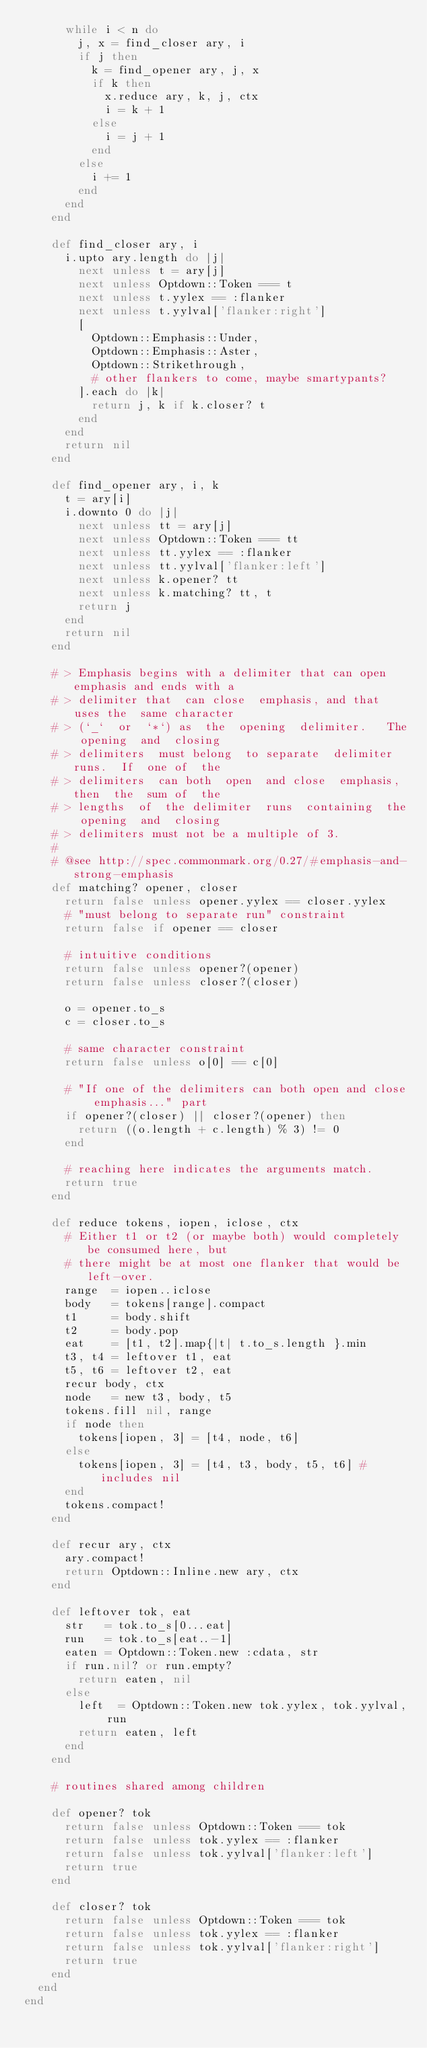Convert code to text. <code><loc_0><loc_0><loc_500><loc_500><_Ruby_>      while i < n do
        j, x = find_closer ary, i
        if j then
          k = find_opener ary, j, x
          if k then
            x.reduce ary, k, j, ctx
            i = k + 1
          else
            i = j + 1
          end
        else
          i += 1
        end
      end
    end

    def find_closer ary, i
      i.upto ary.length do |j|
        next unless t = ary[j]
        next unless Optdown::Token === t
        next unless t.yylex == :flanker
        next unless t.yylval['flanker:right']
        [
          Optdown::Emphasis::Under,
          Optdown::Emphasis::Aster,
          Optdown::Strikethrough,
          # other flankers to come, maybe smartypants?
        ].each do |k|
          return j, k if k.closer? t
        end
      end
      return nil
    end

    def find_opener ary, i, k
      t = ary[i]
      i.downto 0 do |j|
        next unless tt = ary[j]
        next unless Optdown::Token === tt
        next unless tt.yylex == :flanker
        next unless tt.yylval['flanker:left']
        next unless k.opener? tt
        next unless k.matching? tt, t
        return j
      end
      return nil
    end

    # > Emphasis begins with a delimiter that can open emphasis and ends with a
    # > delimiter that  can close  emphasis, and that  uses the  same character
    # > (`_`  or  `*`) as  the  opening  delimiter.   The opening  and  closing
    # > delimiters  must belong  to separate  delimiter  runs.  If  one of  the
    # > delimiters  can both  open  and close  emphasis, then  the  sum of  the
    # > lengths  of  the delimiter  runs  containing  the opening  and  closing
    # > delimiters must not be a multiple of 3.
    #
    # @see http://spec.commonmark.org/0.27/#emphasis-and-strong-emphasis
    def matching? opener, closer
      return false unless opener.yylex == closer.yylex
      # "must belong to separate run" constraint
      return false if opener == closer

      # intuitive conditions
      return false unless opener?(opener)
      return false unless closer?(closer)

      o = opener.to_s
      c = closer.to_s

      # same character constraint
      return false unless o[0] == c[0]

      # "If one of the delimiters can both open and close emphasis..." part
      if opener?(closer) || closer?(opener) then
        return ((o.length + c.length) % 3) != 0
      end

      # reaching here indicates the arguments match.
      return true
    end

    def reduce tokens, iopen, iclose, ctx
      # Either t1 or t2 (or maybe both) would completely be consumed here, but
      # there might be at most one flanker that would be left-over.
      range  = iopen..iclose
      body   = tokens[range].compact
      t1     = body.shift
      t2     = body.pop
      eat    = [t1, t2].map{|t| t.to_s.length }.min
      t3, t4 = leftover t1, eat
      t5, t6 = leftover t2, eat
      recur body, ctx
      node   = new t3, body, t5
      tokens.fill nil, range
      if node then
        tokens[iopen, 3] = [t4, node, t6]
      else
        tokens[iopen, 3] = [t4, t3, body, t5, t6] # includes nil
      end
      tokens.compact!
    end

    def recur ary, ctx
      ary.compact!
      return Optdown::Inline.new ary, ctx
    end

    def leftover tok, eat
      str   = tok.to_s[0...eat]
      run   = tok.to_s[eat..-1]
      eaten = Optdown::Token.new :cdata, str
      if run.nil? or run.empty?
        return eaten, nil
      else
        left  = Optdown::Token.new tok.yylex, tok.yylval, run
        return eaten, left
      end
    end

    # routines shared among children

    def opener? tok
      return false unless Optdown::Token === tok
      return false unless tok.yylex == :flanker
      return false unless tok.yylval['flanker:left']
      return true
    end

    def closer? tok
      return false unless Optdown::Token === tok
      return false unless tok.yylex == :flanker
      return false unless tok.yylval['flanker:right']
      return true
    end
  end
end
</code> 